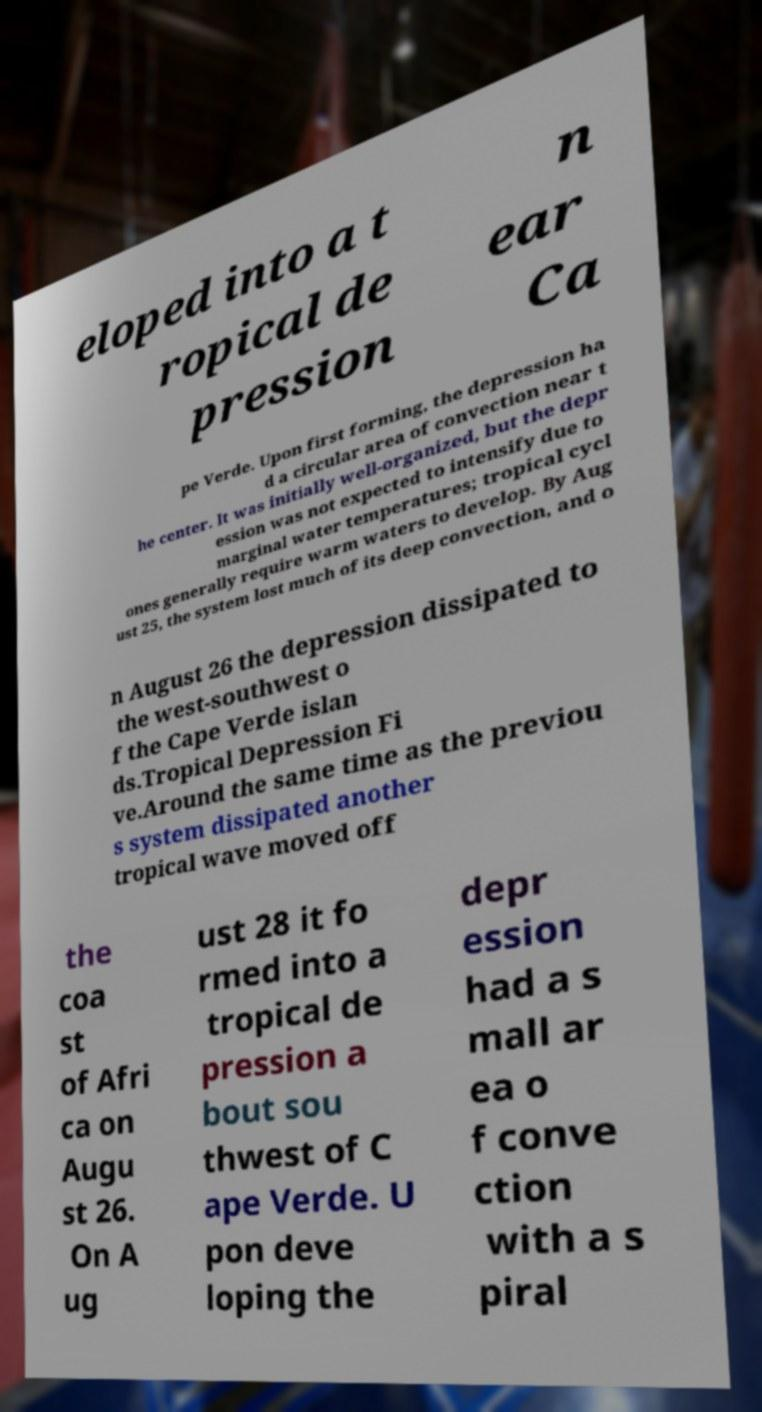For documentation purposes, I need the text within this image transcribed. Could you provide that? eloped into a t ropical de pression n ear Ca pe Verde. Upon first forming, the depression ha d a circular area of convection near t he center. It was initially well-organized, but the depr ession was not expected to intensify due to marginal water temperatures; tropical cycl ones generally require warm waters to develop. By Aug ust 25, the system lost much of its deep convection, and o n August 26 the depression dissipated to the west-southwest o f the Cape Verde islan ds.Tropical Depression Fi ve.Around the same time as the previou s system dissipated another tropical wave moved off the coa st of Afri ca on Augu st 26. On A ug ust 28 it fo rmed into a tropical de pression a bout sou thwest of C ape Verde. U pon deve loping the depr ession had a s mall ar ea o f conve ction with a s piral 